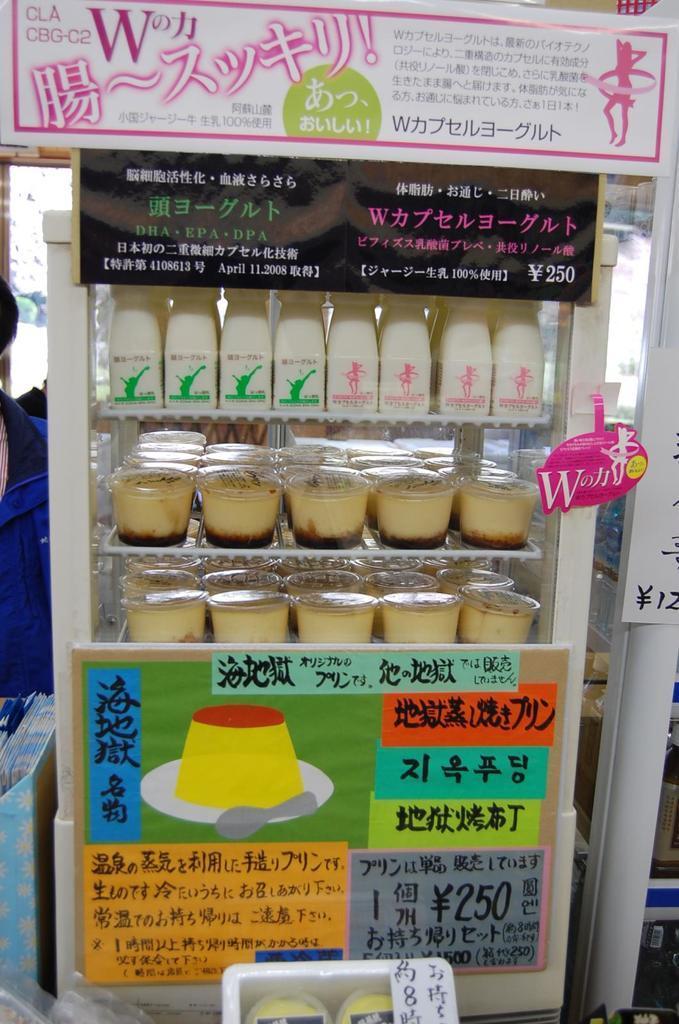How would you summarize this image in a sentence or two? In the foreground of the picture we can see a vending machine, in which there are many products. In this picture there are boards. In the background there are some objects which are not clear. 